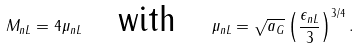<formula> <loc_0><loc_0><loc_500><loc_500>M _ { n L } = 4 \mu _ { n L } \quad \text {with} \quad \mu _ { n L } = \sqrt { a _ { G } } \left ( \frac { \epsilon _ { n L } } { 3 } \right ) ^ { 3 / 4 } .</formula> 